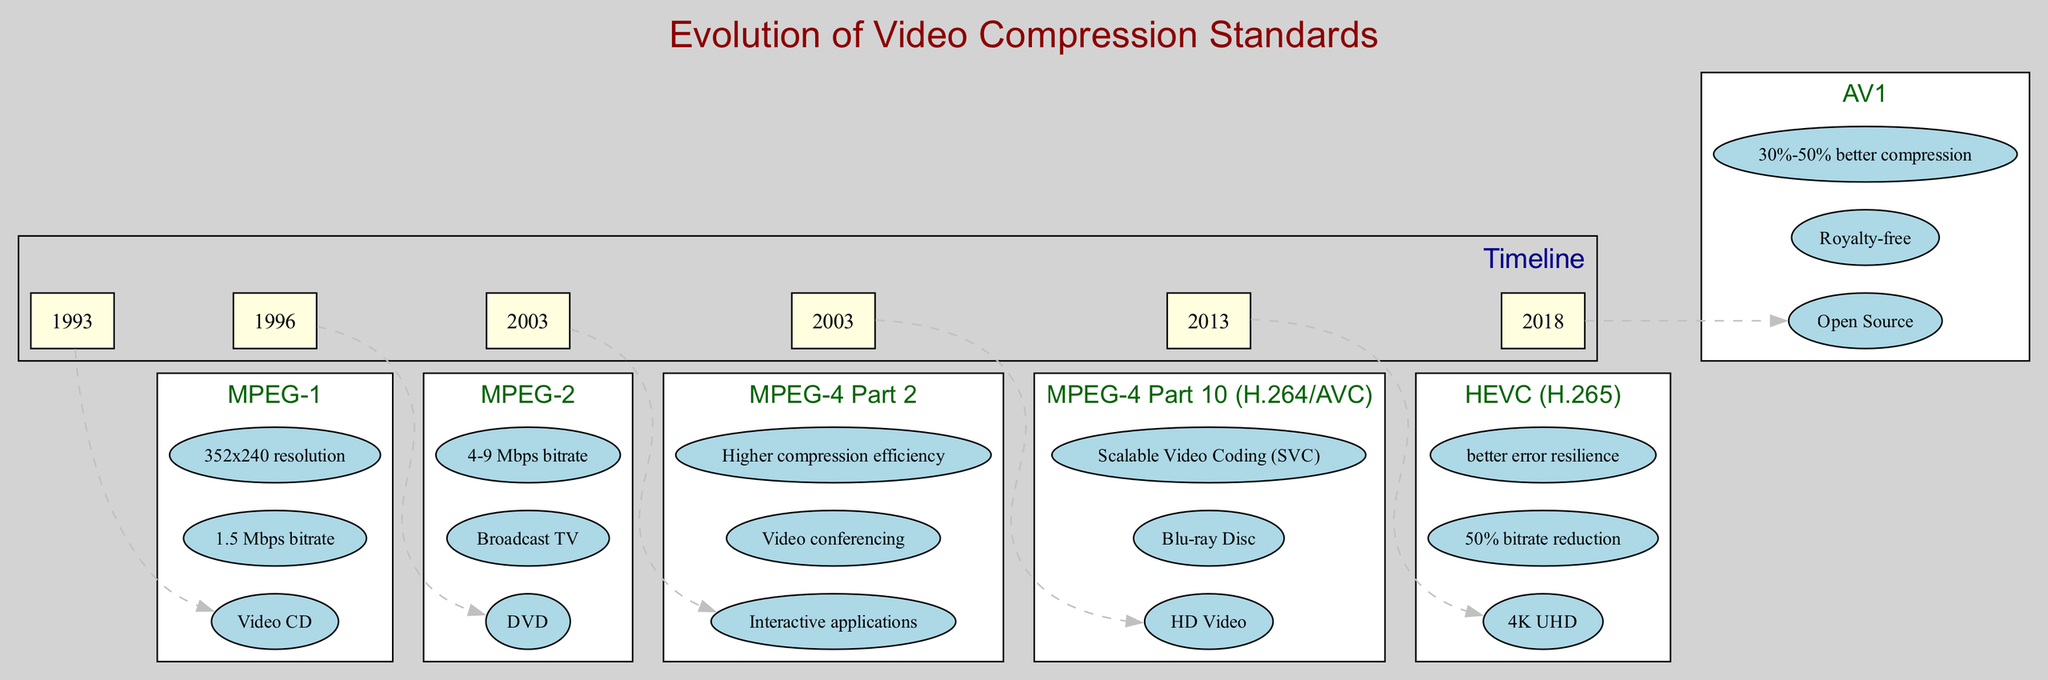What standard was introduced in 1993? The diagram indicates that the standard introduced in 1993 is MPEG-1, as it is the first node on the timeline.
Answer: MPEG-1 What is a key feature of HEVC (H.265)? The diagram lists several key features for HEVC (H.265), one of which is a 50% bitrate reduction. This can be found in the section dedicated to HEVC on the timeline.
Answer: 50% bitrate reduction How many years apart were MPEG-2 and HEVC (H.265) introduced? By subtracting the year of MPEG-2 (1996) from the year of HEVC (H.265) (2013), we find that they were introduced 17 years apart.
Answer: 17 years Which video compression standard is open source? According to the timeline, AV1 is specified as being open source, which clearly identifies it among the listed standards.
Answer: AV1 Which standard supports Blu-ray Disc? The diagram specifies that MPEG-4 Part 10 (H.264/AVC) supports Blu-ray Disc as one of its key features, making it easy to identify.
Answer: MPEG-4 Part 10 (H.264/AVC) What resolution did MPEG-1 support? The timeline states that MPEG-1 supported a resolution of 352x240, making this information direct and specific to the MPEG-1 standard.
Answer: 352x240 resolution What is a common feature of both MPEG-2 and HEVC (H.265)? Both MPEG-2 and HEVC (H.265) mention having improvements in terms of bitrate. While MPEG-2 indicates a bitrate of 4-9 Mbps, HEVC mentions a 50% bitrate reduction, showing a trend of improving bitrate efficiency across time.
Answer: Bitrate improvements What significant improvement does AV1 provide over previous standards? The timeline indicates that AV1 offers 30%-50% better compression compared to previous standards, making this a notable aspect of its design.
Answer: 30%-50% better compression How many more key features does MPEG-4 Part 10 (H.264/AVC) have than MPEG-1? MPEG-1 has three key features while MPEG-4 Part 10 (H.264/AVC) has three as well. They have the same number of key features, which is a point of interest in comparative analysis.
Answer: 0 more features 